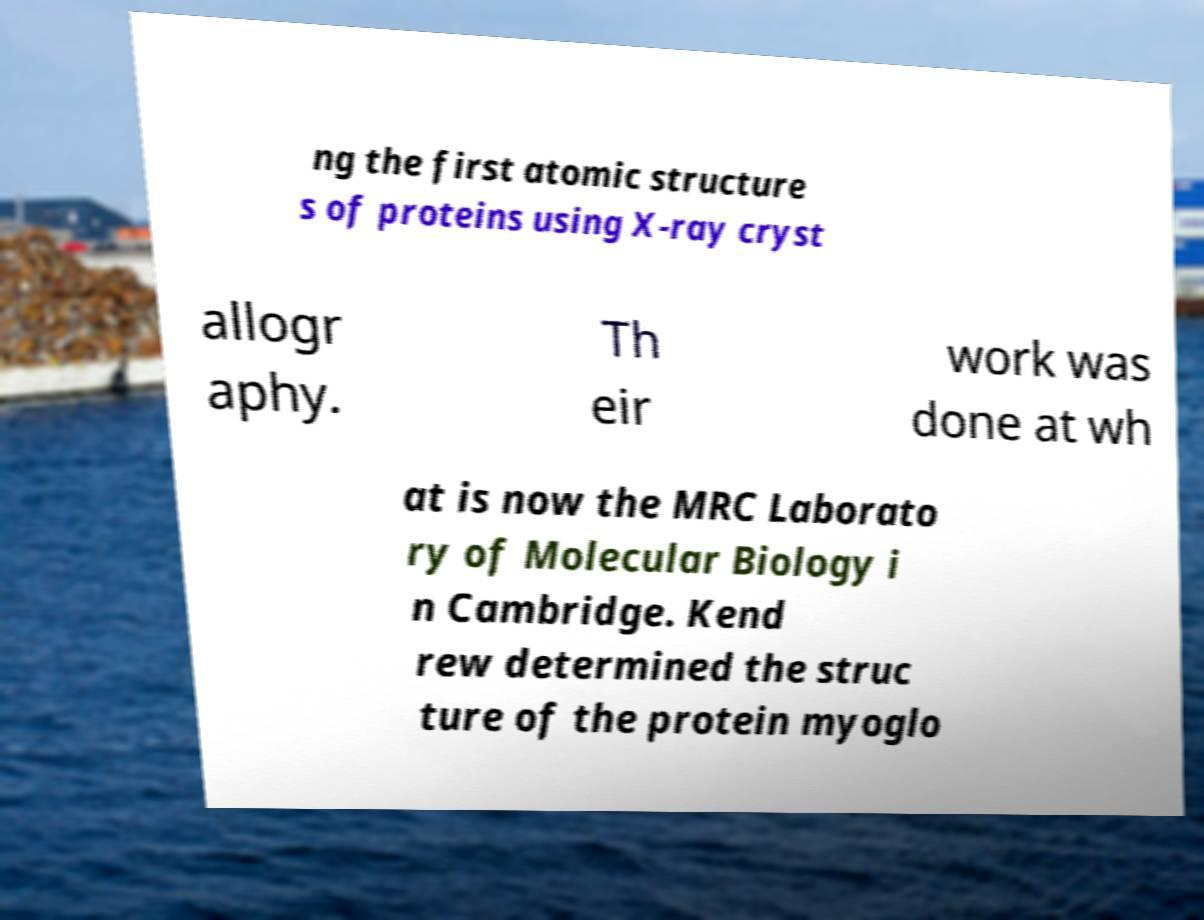Please read and relay the text visible in this image. What does it say? ng the first atomic structure s of proteins using X-ray cryst allogr aphy. Th eir work was done at wh at is now the MRC Laborato ry of Molecular Biology i n Cambridge. Kend rew determined the struc ture of the protein myoglo 